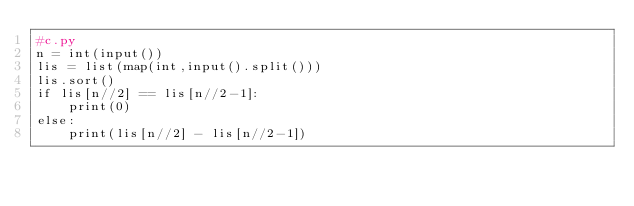Convert code to text. <code><loc_0><loc_0><loc_500><loc_500><_Python_>#c.py
n = int(input())
lis = list(map(int,input().split()))
lis.sort()
if lis[n//2] == lis[n//2-1]:
    print(0)
else:
    print(lis[n//2] - lis[n//2-1])</code> 